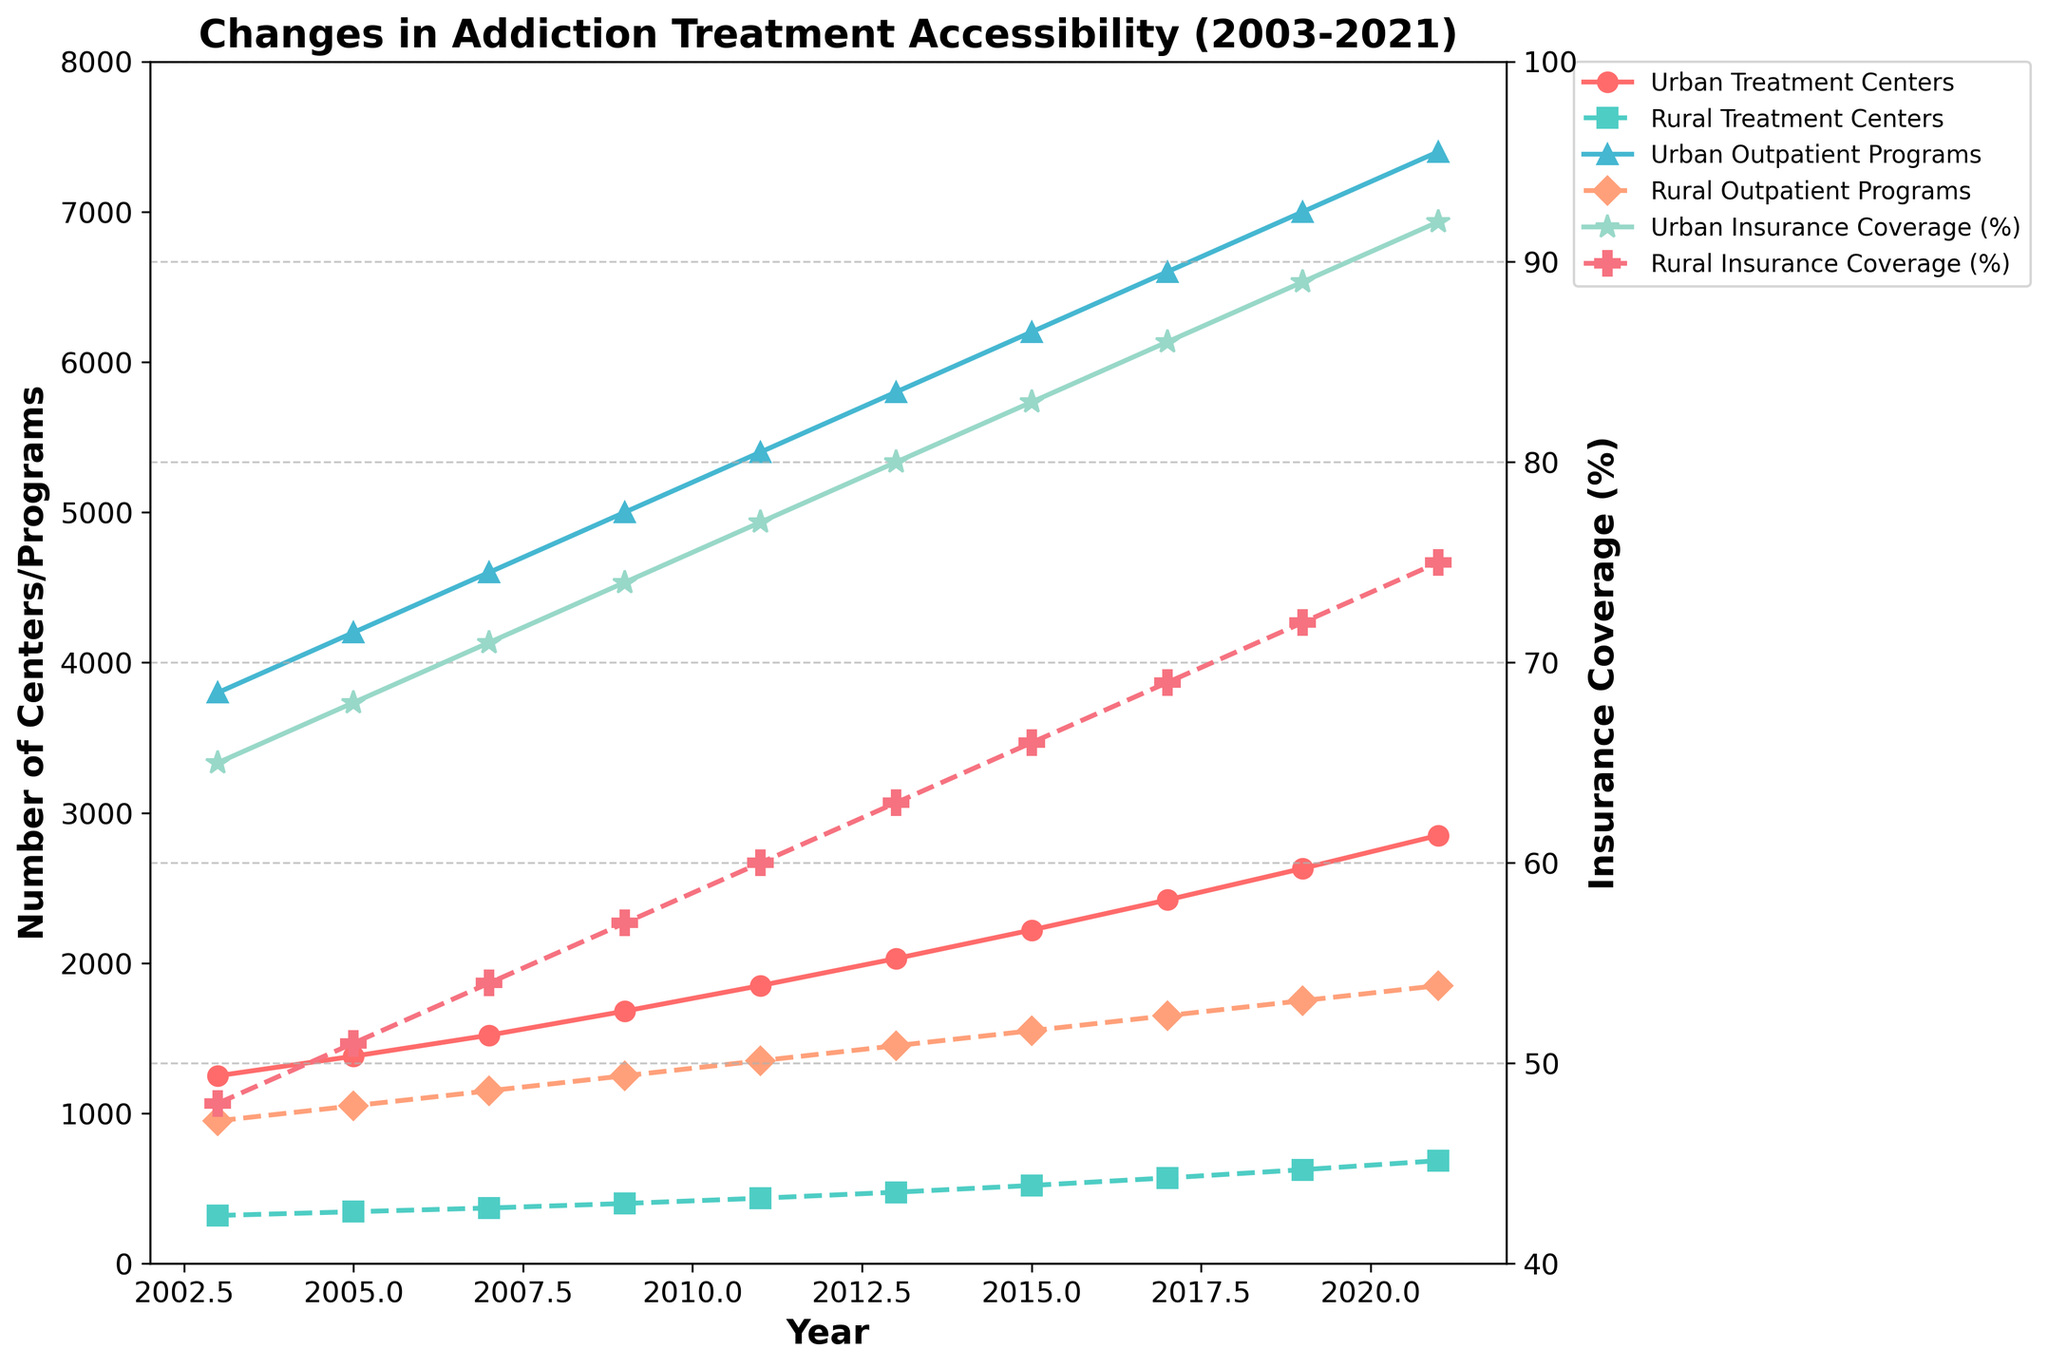What is the trend in the number of urban treatment centers from 2003 to 2021? To find the trend, observe the line representing "Urban Treatment Centers" from 2003 to 2021. The line shows a steady increase in the number of urban treatment centers over the years.
Answer: Steady increase How does the number of rural outpatient programs in 2021 compare to that in 2003? Observe the line representing "Rural Outpatient Programs" in 2003 and 2021. In 2003, there were 950 programs, and in 2021, there were 1850 programs, indicating an increase.
Answer: Increased What is the difference in insurance coverage percentage between urban and rural areas in 2021? Check the lines representing "Urban Insurance Coverage (%)" and "Rural Insurance Coverage (%)" for the year 2021. Urban insurance coverage is 92%, and rural insurance coverage is 75%. The difference is 92% - 75% = 17%.
Answer: 17% Which year saw the largest increase in urban treatment centers? Examine the line representing "Urban Treatment Centers" and compare the increments between consecutive years. The largest increase appears between 2019 (2630 centers) and 2021 (2850 centers), which is 220 centers (2850 - 2630).
Answer: 2019 to 2021 What is the average number of rural outpatient programs from 2003 to 2021? Sum the number of rural outpatient programs for each year and divide by the number of years. (950 + 1050 + 1150 + 1250 + 1350 + 1450 + 1550 + 1650 + 1750 + 1850) / 10 = 14050 / 10 = 1405.
Answer: 1405 During which period did rural insurance coverage see a significant rise? Observe the line representing "Rural Insurance Coverage (%)" and note the periods between the years where there is a noticeable increase. A significant rise is seen between 2015 (66%) and 2017 (69%), a 3% increase.
Answer: 2015 to 2017 Which line is represented with square markers and what does it indicate? Identify the line with square markers by observation. The line with square markers represents "Rural Treatment Centers."
Answer: Rural Treatment Centers By how many did the number of urban outpatient programs increase from 2013 to 2017? Observe the line representing "Urban Outpatient Programs" for the years 2013 and 2017. In 2013, the number was 5800, and in 2017 it was 6600. The increase is 6600 - 5800 = 800 programs.
Answer: 800 Comparing rural and urban insurance coverage in 2009, which one was higher and by how much? Check the lines representing "Urban Insurance Coverage (%)" and "Rural Insurance Coverage (%)" for the year 2009. Urban coverage was 74%, and rural coverage was 57%. The difference is 74% - 57% = 17%. Urban coverage was higher.
Answer: Urban, 17% What is the visual difference between urban and rural outpatient program lines? Observe the visual attributes of the lines representing "Urban Outpatient Programs" and "Rural Outpatient Programs." The urban line is solid with triangle markers, while the rural line is dashed with diamond markers.
Answer: Solid line with triangles vs. dashed line with diamonds 